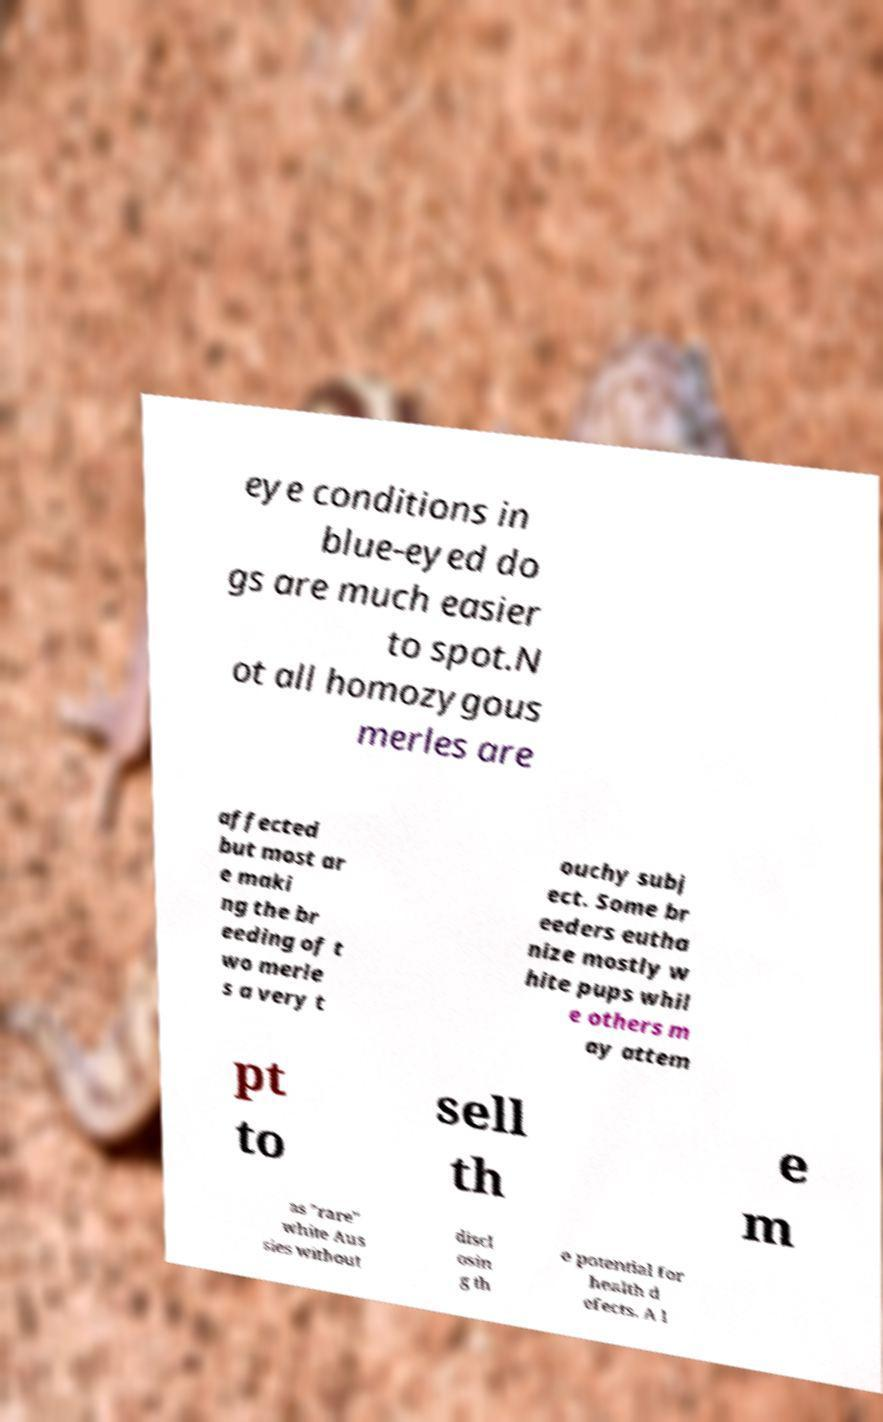What messages or text are displayed in this image? I need them in a readable, typed format. eye conditions in blue-eyed do gs are much easier to spot.N ot all homozygous merles are affected but most ar e maki ng the br eeding of t wo merle s a very t ouchy subj ect. Some br eeders eutha nize mostly w hite pups whil e others m ay attem pt to sell th e m as "rare" white Aus sies without discl osin g th e potential for health d efects. A l 